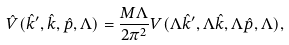<formula> <loc_0><loc_0><loc_500><loc_500>\hat { V } ( \hat { k } ^ { \prime } , \hat { k } , \hat { p } , \Lambda ) = \frac { M \Lambda } { 2 \pi ^ { 2 } } V ( \Lambda \hat { k } ^ { \prime } , \Lambda \hat { k } , \Lambda \hat { p } , \Lambda ) ,</formula> 